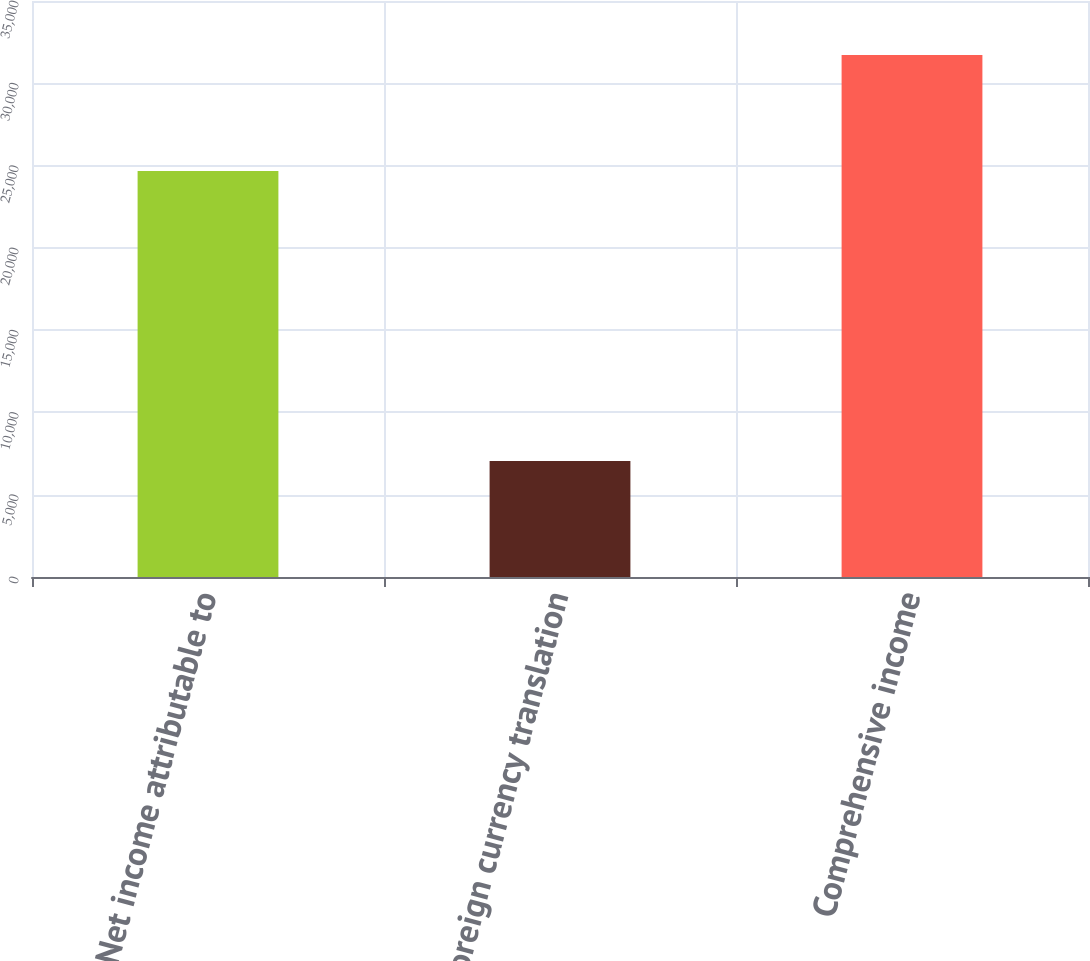Convert chart. <chart><loc_0><loc_0><loc_500><loc_500><bar_chart><fcel>Net income attributable to<fcel>Foreign currency translation<fcel>Comprehensive income<nl><fcel>24666<fcel>7054<fcel>31720<nl></chart> 